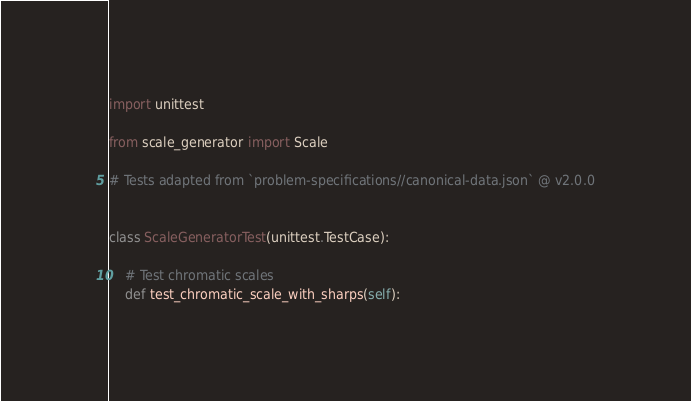Convert code to text. <code><loc_0><loc_0><loc_500><loc_500><_Python_>import unittest

from scale_generator import Scale

# Tests adapted from `problem-specifications//canonical-data.json` @ v2.0.0


class ScaleGeneratorTest(unittest.TestCase):

    # Test chromatic scales
    def test_chromatic_scale_with_sharps(self):</code> 